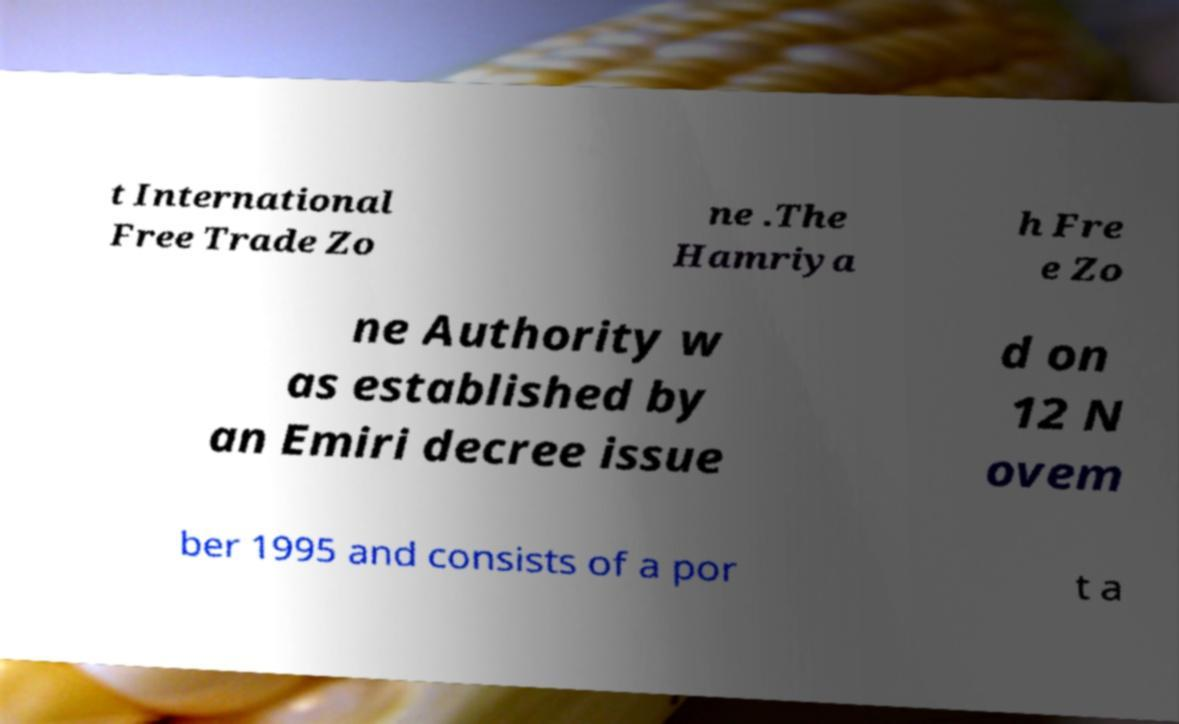For documentation purposes, I need the text within this image transcribed. Could you provide that? t International Free Trade Zo ne .The Hamriya h Fre e Zo ne Authority w as established by an Emiri decree issue d on 12 N ovem ber 1995 and consists of a por t a 